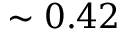Convert formula to latex. <formula><loc_0><loc_0><loc_500><loc_500>\sim 0 . 4 2</formula> 